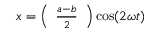<formula> <loc_0><loc_0><loc_500><loc_500>x = \left ( { \begin{array} { l } { { \frac { a - b } { 2 } } } \end{array} } \right ) \cos ( 2 \omega t )</formula> 